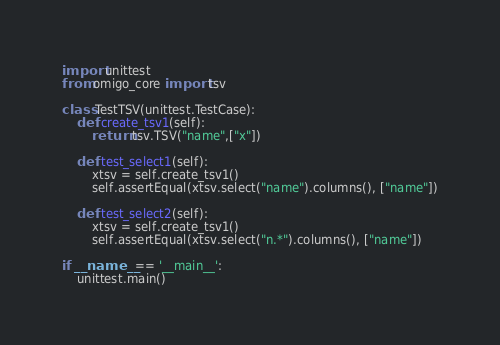<code> <loc_0><loc_0><loc_500><loc_500><_Python_>import unittest
from omigo_core import tsv

class TestTSV(unittest.TestCase):
    def create_tsv1(self):
        return tsv.TSV("name",["x"])

    def test_select1(self):
        xtsv = self.create_tsv1()
        self.assertEqual(xtsv.select("name").columns(), ["name"])

    def test_select2(self):
        xtsv = self.create_tsv1()
        self.assertEqual(xtsv.select("n.*").columns(), ["name"])

if __name__ == '__main__':
    unittest.main()
</code> 